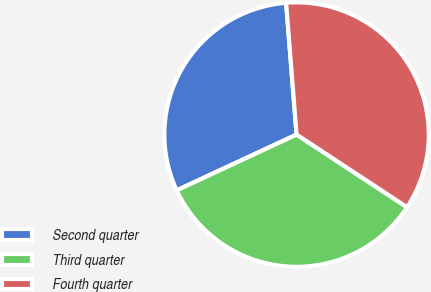Convert chart. <chart><loc_0><loc_0><loc_500><loc_500><pie_chart><fcel>Second quarter<fcel>Third quarter<fcel>Fourth quarter<nl><fcel>30.67%<fcel>33.81%<fcel>35.51%<nl></chart> 